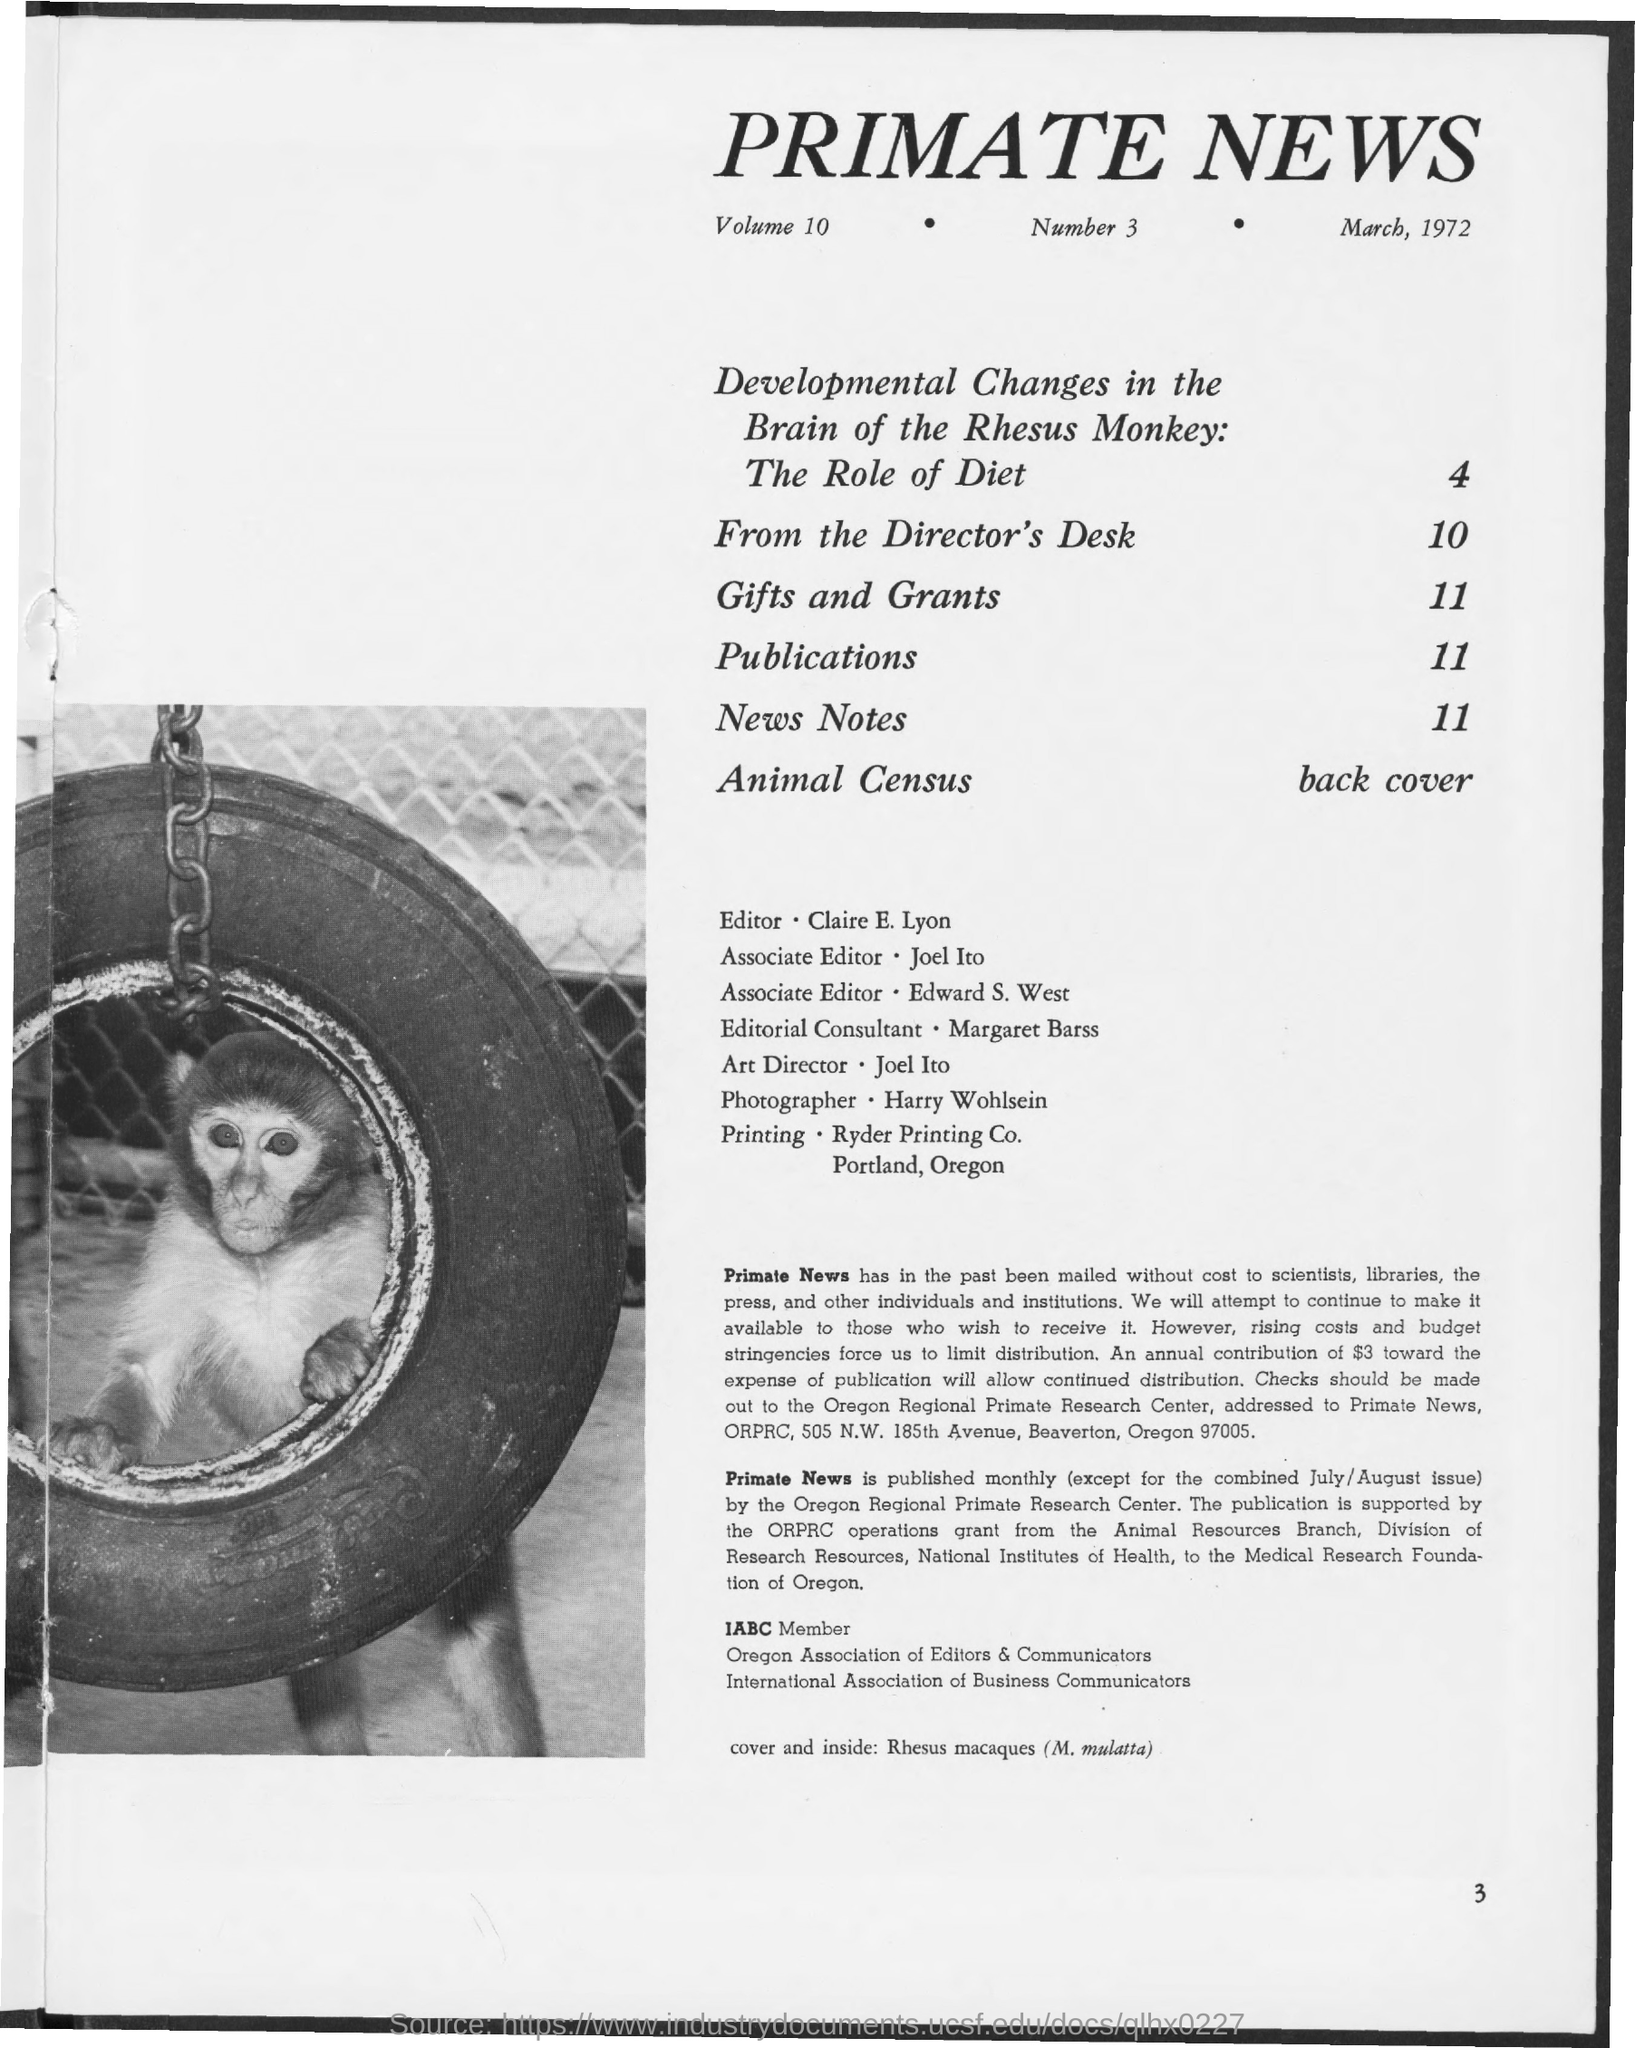Outline some significant characteristics in this image. Joel Ito is the Art Director. Please inform me of the page number where 'New Notes' can be found, ranging from 11. The photographer is Harry Wohlsein. The title of the document is "Primate News. The identity of the editor is Claire E. Lyon. 